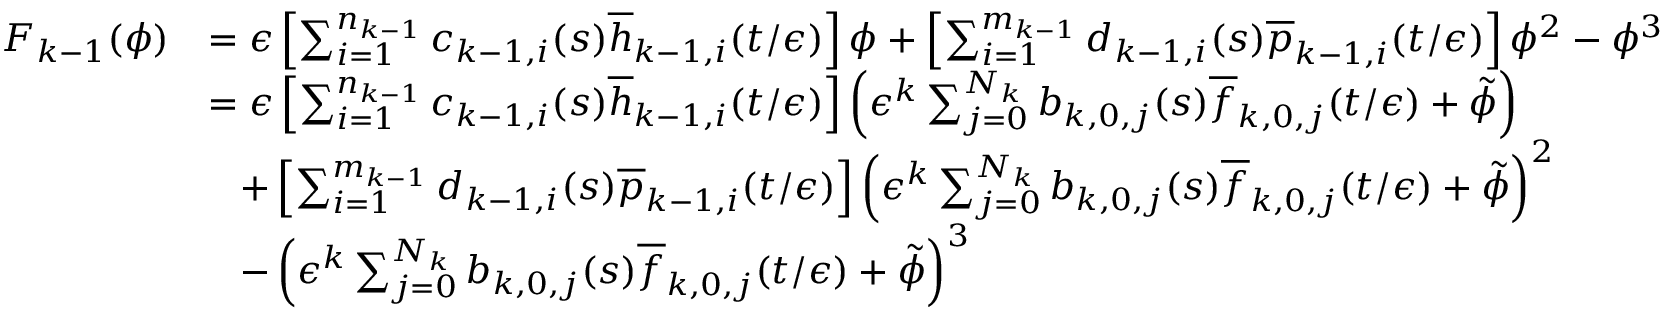Convert formula to latex. <formula><loc_0><loc_0><loc_500><loc_500>\begin{array} { r l } { F _ { k - 1 } ( \phi ) } & { = \epsilon \left [ \sum _ { i = 1 } ^ { n _ { k - 1 } } c _ { k - 1 , i } ( s ) \overline { h } _ { k - 1 , i } ( t / \epsilon ) \right ] \phi + \left [ \sum _ { i = 1 } ^ { m _ { k - 1 } } d _ { k - 1 , i } ( s ) \overline { p } _ { k - 1 , i } ( t / \epsilon ) \right ] \phi ^ { 2 } - \phi ^ { 3 } } \\ & { = \epsilon \left [ \sum _ { i = 1 } ^ { n _ { k - 1 } } c _ { k - 1 , i } ( s ) \overline { h } _ { k - 1 , i } ( t / \epsilon ) \right ] \left ( \epsilon ^ { k } \sum _ { j = 0 } ^ { N _ { k } } b _ { k , 0 , j } ( s ) \overline { f } _ { k , 0 , j } ( t / \epsilon ) + \tilde { \phi } \right ) } \\ & { \, + \left [ \sum _ { i = 1 } ^ { m _ { k - 1 } } d _ { k - 1 , i } ( s ) \overline { p } _ { k - 1 , i } ( t / \epsilon ) \right ] \left ( \epsilon ^ { k } \sum _ { j = 0 } ^ { N _ { k } } b _ { k , 0 , j } ( s ) \overline { f } _ { k , 0 , j } ( t / \epsilon ) + \tilde { \phi } \right ) ^ { 2 } } \\ & { \, - \left ( \epsilon ^ { k } \sum _ { j = 0 } ^ { N _ { k } } b _ { k , 0 , j } ( s ) \overline { f } _ { k , 0 , j } ( t / \epsilon ) + \tilde { \phi } \right ) ^ { 3 } } \end{array}</formula> 